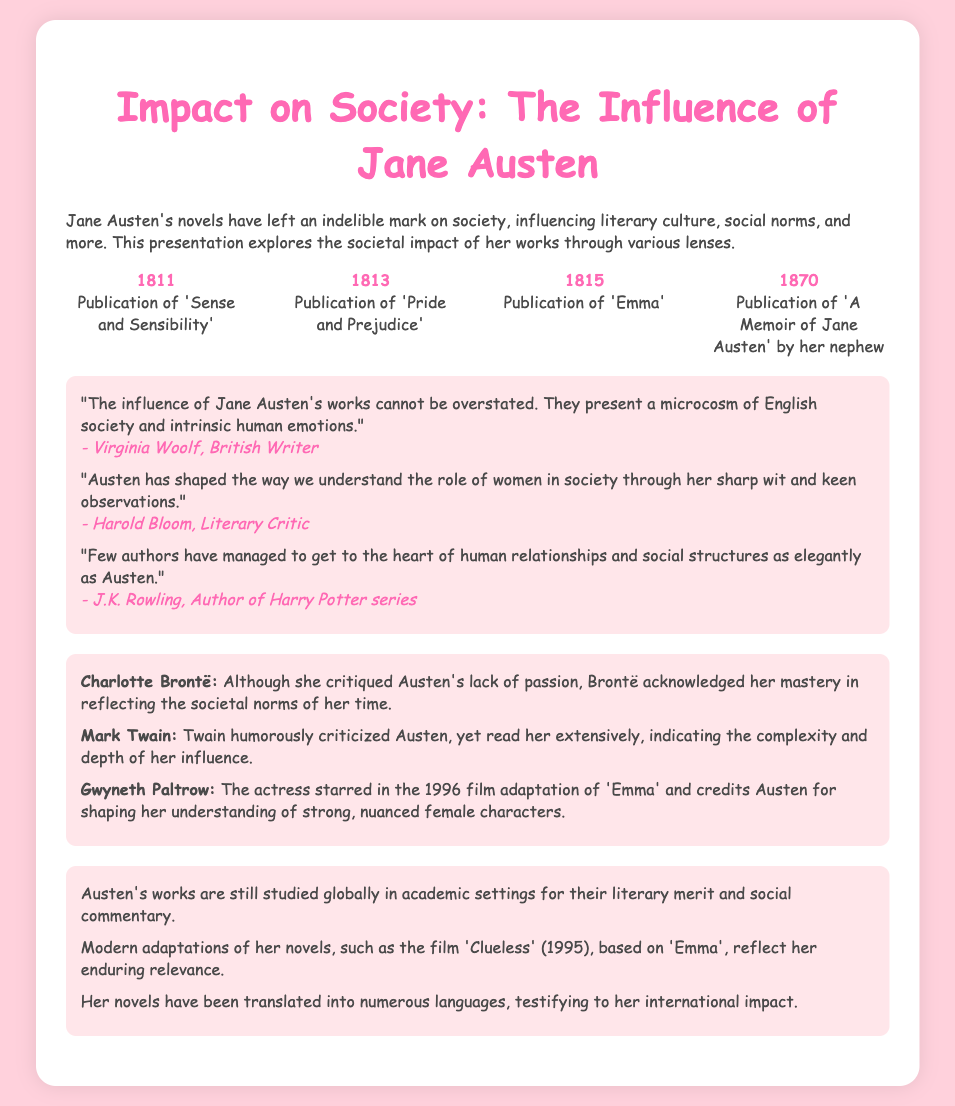What year was 'Sense and Sensibility' published? The slide states that 'Sense and Sensibility' was published in the year 1811.
Answer: 1811 Who authored the quote about the microcosm of English society? Virginia Woolf, a British writer, is credited with acknowledging Austen's representation of society.
Answer: Virginia Woolf What notable film adaptation is mentioned related to 'Emma'? The slide highlights the film 'Clueless' (1995) as a modern adaptation of Austen's 'Emma'.
Answer: Clueless Which author criticized Austen's lack of passion? Charlotte Brontë is mentioned as having critiqued Austen for her lack of passion.
Answer: Charlotte Brontë How many major works of Austen are listed in the timeline? The timeline features four major works published by Austen, indicating her literary contributions.
Answer: Four What significant impact did Austen's works have according to the slide? Her novels are still studied globally for their literary merit and social commentary.
Answer: Studied globally Which author mentioned Austen's ability to reflect societal norms? Harold Bloom, a literary critic, recognized Austen's brilliance in observing societal norms.
Answer: Harold Bloom What year did Jane Austen pass away? The slide does not provide this information directly, focusing instead on her publications and impact.
Answer: Not provided 